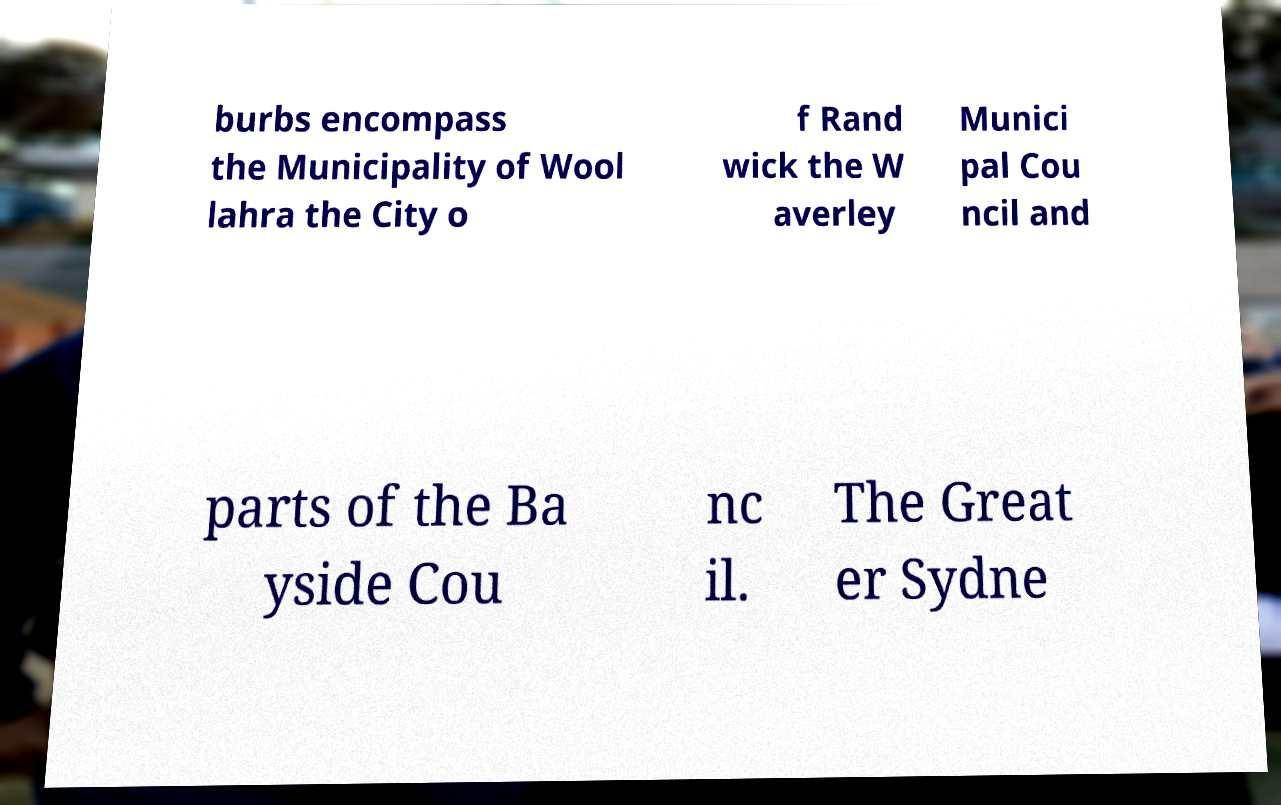Please identify and transcribe the text found in this image. burbs encompass the Municipality of Wool lahra the City o f Rand wick the W averley Munici pal Cou ncil and parts of the Ba yside Cou nc il. The Great er Sydne 